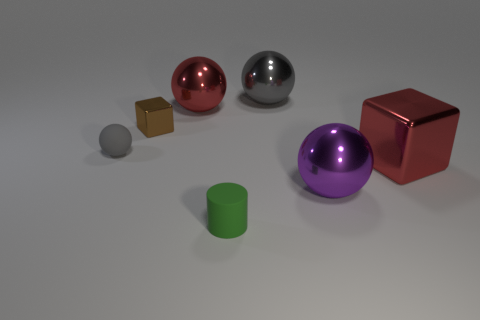Subtract all blue spheres. Subtract all red cylinders. How many spheres are left? 4 Add 3 red metallic things. How many objects exist? 10 Subtract all cylinders. How many objects are left? 6 Add 2 tiny objects. How many tiny objects are left? 5 Add 5 red metallic cylinders. How many red metallic cylinders exist? 5 Subtract 0 cyan cylinders. How many objects are left? 7 Subtract all tiny cylinders. Subtract all metallic balls. How many objects are left? 3 